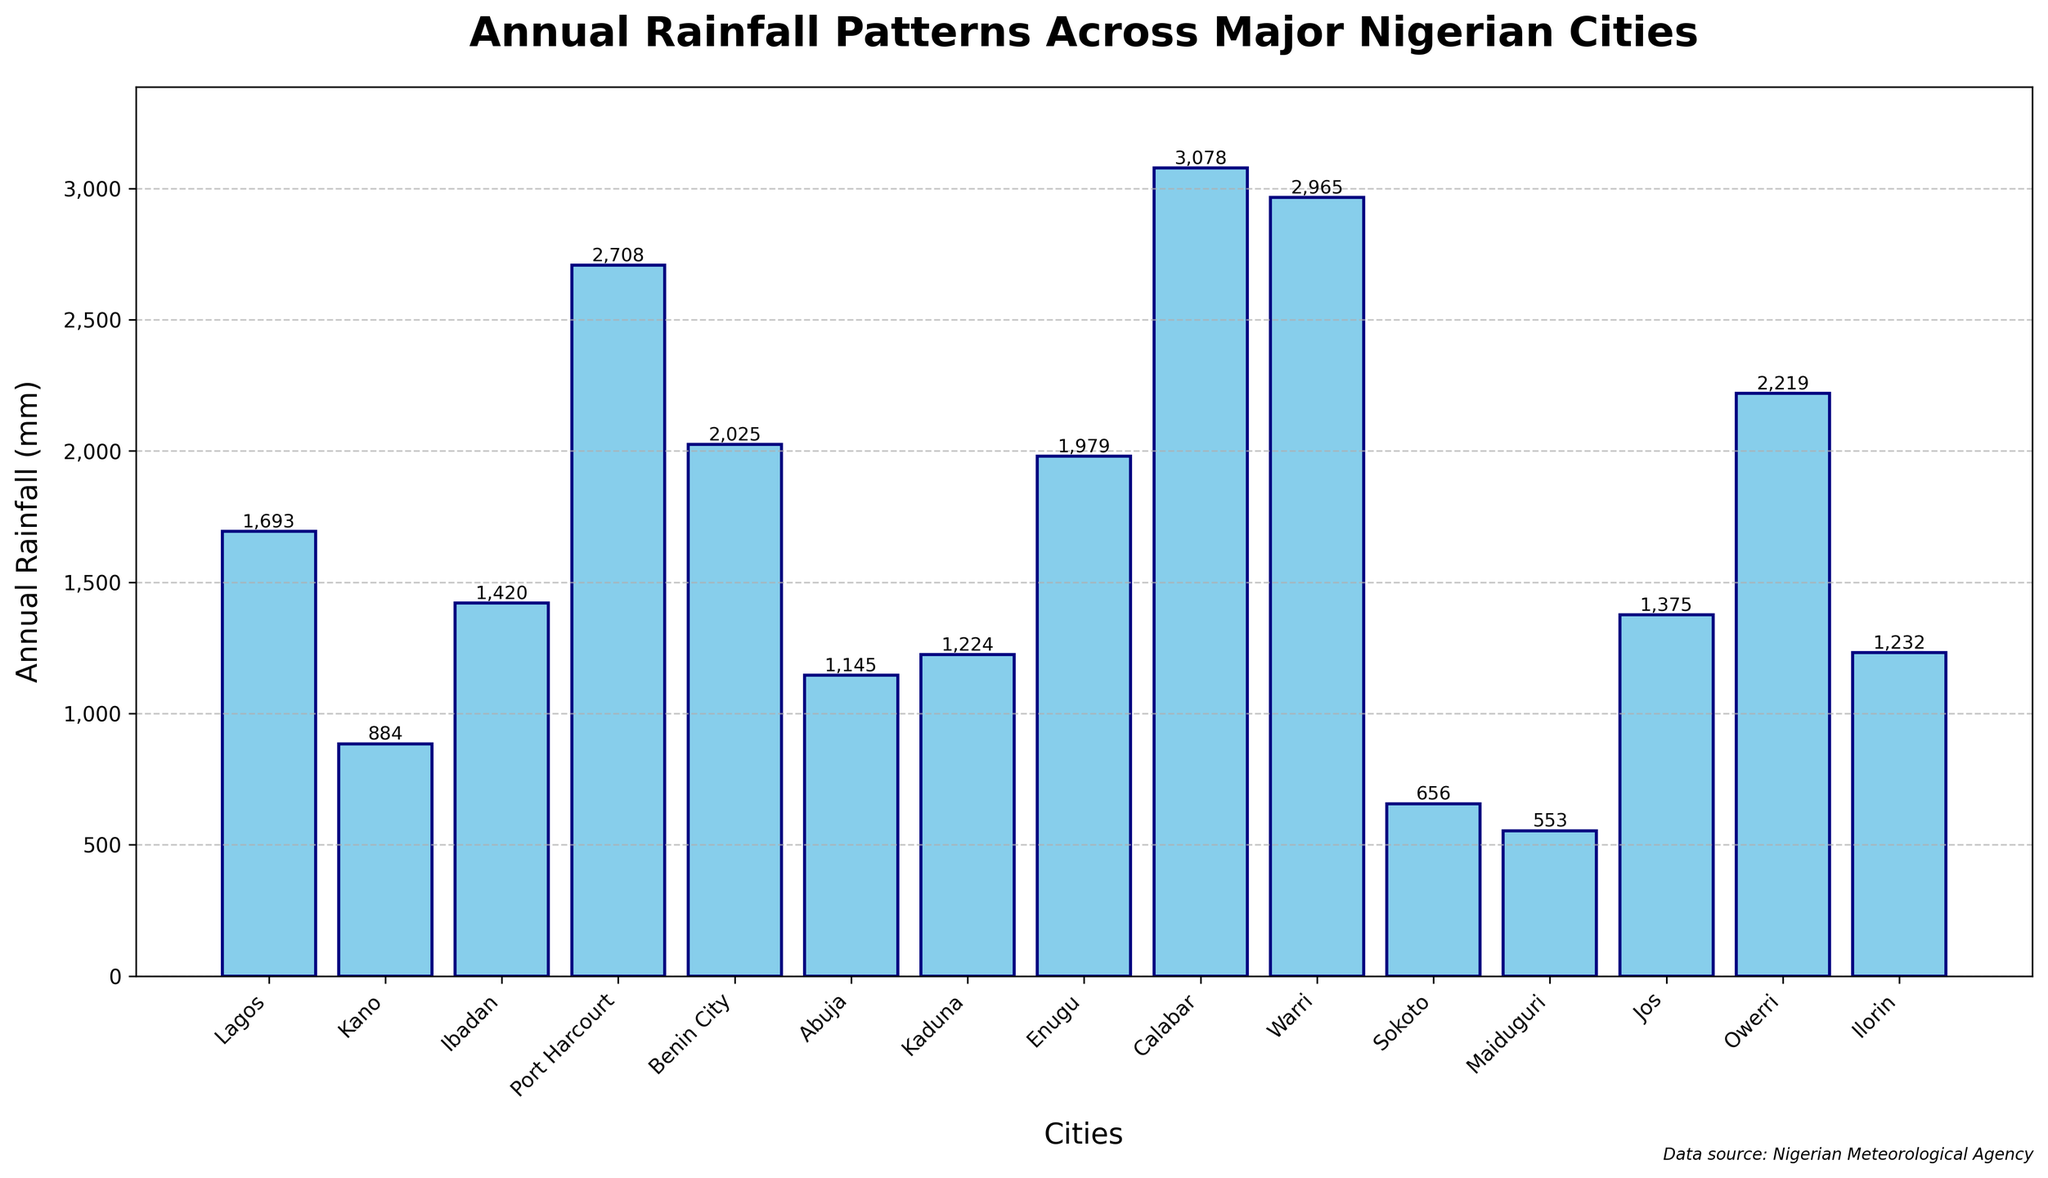Which city has the highest annual rainfall? Look for the tallest bar in the chart. Calabar stands out as the tallest bar.
Answer: Calabar Which city has the lowest annual rainfall? Look for the shortest bar in the chart. Maiduguri is the shortest bar.
Answer: Maiduguri What is the difference in annual rainfall between Calabar and Lagos? Find the heights of the bars for Calabar (3078 mm) and Lagos (1693 mm), then calculate the difference (3078 - 1693).
Answer: 1385 mm Which cities have more annual rainfall than Abuja? Identify the bar for Abuja (1145 mm), then compare the heights of other bars to see which are taller. Lagos, Ibadan, Port Harcourt, Benin City, Kaduna, Enugu, Calabar, Warri, Ilorin, and Owerri have more rainfall than Abuja.
Answer: Lagos, Ibadan, Port Harcourt, Benin City, Kaduna, Enugu, Calabar, Warri, Ilorin, Owerri What is the total annual rainfall for the cities of Port Harcourt and Warri combined? Add the heights of the bars for Port Harcourt (2708 mm) and Warri (2965 mm).
Answer: 5673 mm Which two cities have the most similar annual rainfall amounts? Compare the heights of all the bars to find the smallest difference. Kaduna (1224 mm) and Ilorin (1232 mm) are the most similar.
Answer: Kaduna and Ilorin How does the annual rainfall in Benin City compare to that in Enugu? Compare the height of the bar for Benin City (2025 mm) to that of Enugu (1979 mm). Benin City has slightly more rainfall than Enugu.
Answer: Benin City has more Is the difference in annual rainfall between Kano and Sokoto more or less than 250 mm? Find the heights of the bars for Kano (884 mm) and Sokoto (656 mm), then calculate the difference (884 - 656). The difference is 228 mm, which is less than 250 mm.
Answer: Less What is the average annual rainfall of the three cities with the highest rainfall? Identify the heights of the top three bars: Calabar (3078 mm), Warri (2965 mm), and Port Harcourt (2708 mm). Add them (3078 + 2965 + 2708 = 8751) and divide by 3.
Answer: 2917 mm 